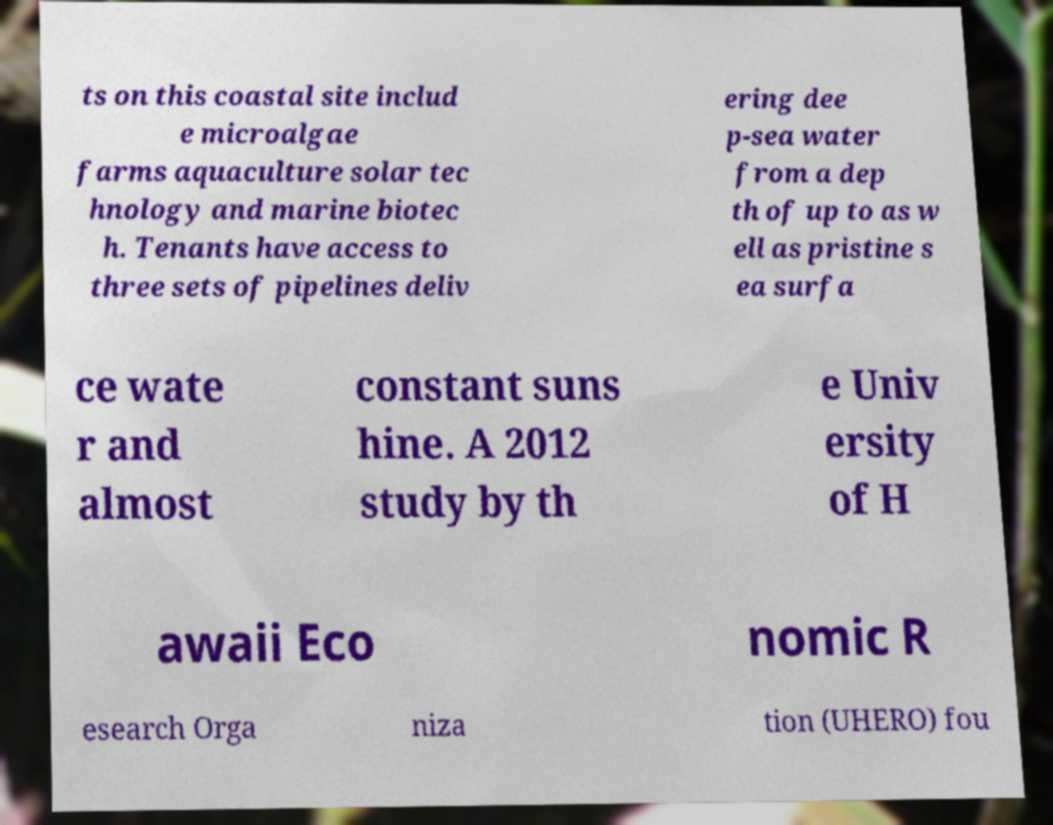For documentation purposes, I need the text within this image transcribed. Could you provide that? ts on this coastal site includ e microalgae farms aquaculture solar tec hnology and marine biotec h. Tenants have access to three sets of pipelines deliv ering dee p-sea water from a dep th of up to as w ell as pristine s ea surfa ce wate r and almost constant suns hine. A 2012 study by th e Univ ersity of H awaii Eco nomic R esearch Orga niza tion (UHERO) fou 